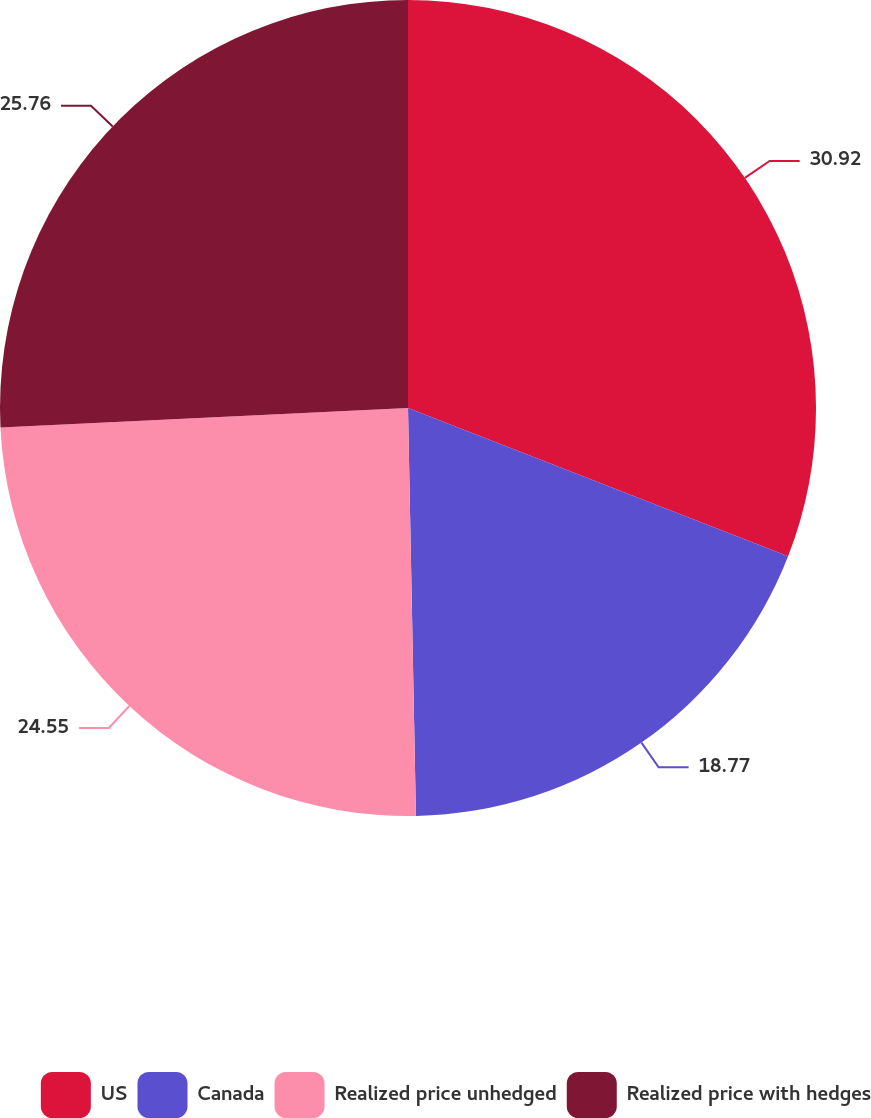Convert chart to OTSL. <chart><loc_0><loc_0><loc_500><loc_500><pie_chart><fcel>US<fcel>Canada<fcel>Realized price unhedged<fcel>Realized price with hedges<nl><fcel>30.92%<fcel>18.77%<fcel>24.55%<fcel>25.76%<nl></chart> 